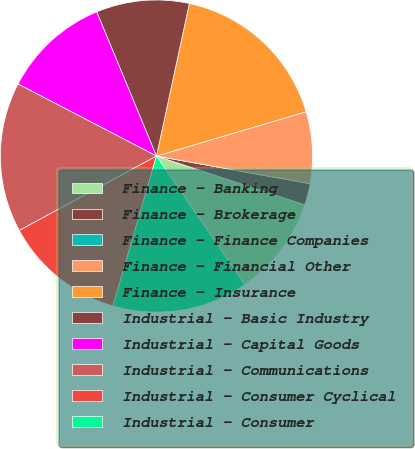Convert chart to OTSL. <chart><loc_0><loc_0><loc_500><loc_500><pie_chart><fcel>Finance - Banking<fcel>Finance - Brokerage<fcel>Finance - Finance Companies<fcel>Finance - Financial Other<fcel>Finance - Insurance<fcel>Industrial - Basic Industry<fcel>Industrial - Capital Goods<fcel>Industrial - Communications<fcel>Industrial - Consumer Cyclical<fcel>Industrial - Consumer<nl><fcel>10.37%<fcel>2.22%<fcel>0.0%<fcel>7.41%<fcel>17.04%<fcel>9.63%<fcel>11.11%<fcel>15.55%<fcel>12.59%<fcel>14.07%<nl></chart> 